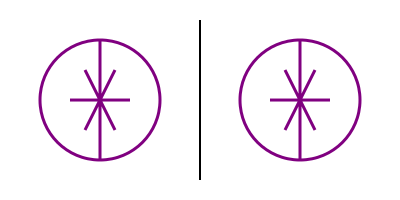Which of the two feminist symbols shown is the mirror image of the other when reflected across the vertical line? To determine if the symbols are mirror images of each other, we need to follow these steps:

1. Identify the key elements of the feminist symbol:
   - A circle
   - A vertical line through the center
   - A horizontal line through the center
   - Two diagonal lines forming an "X"

2. Compare the left and right symbols:
   - Both have the same circle size and position relative to the central line
   - The vertical and horizontal lines are in the same positions in both symbols
   - The diagonal lines in the left symbol go from top-left to bottom-right and top-right to bottom-left
   - The diagonal lines in the right symbol have the same orientation as the left symbol

3. Consider the properties of a mirror image:
   - A mirror image should reverse the left-right orientation of an object
   - Vertical elements remain unchanged
   - Horizontal elements remain unchanged
   - Diagonal elements should be flipped

4. Analyze the diagonal lines:
   - In a true mirror image, the diagonal lines should be reversed
   - However, in this case, the diagonal lines have the same orientation in both symbols

Therefore, the symbols shown are not mirror images of each other when reflected across the vertical line. They are identical copies.
Answer: Not mirror images 